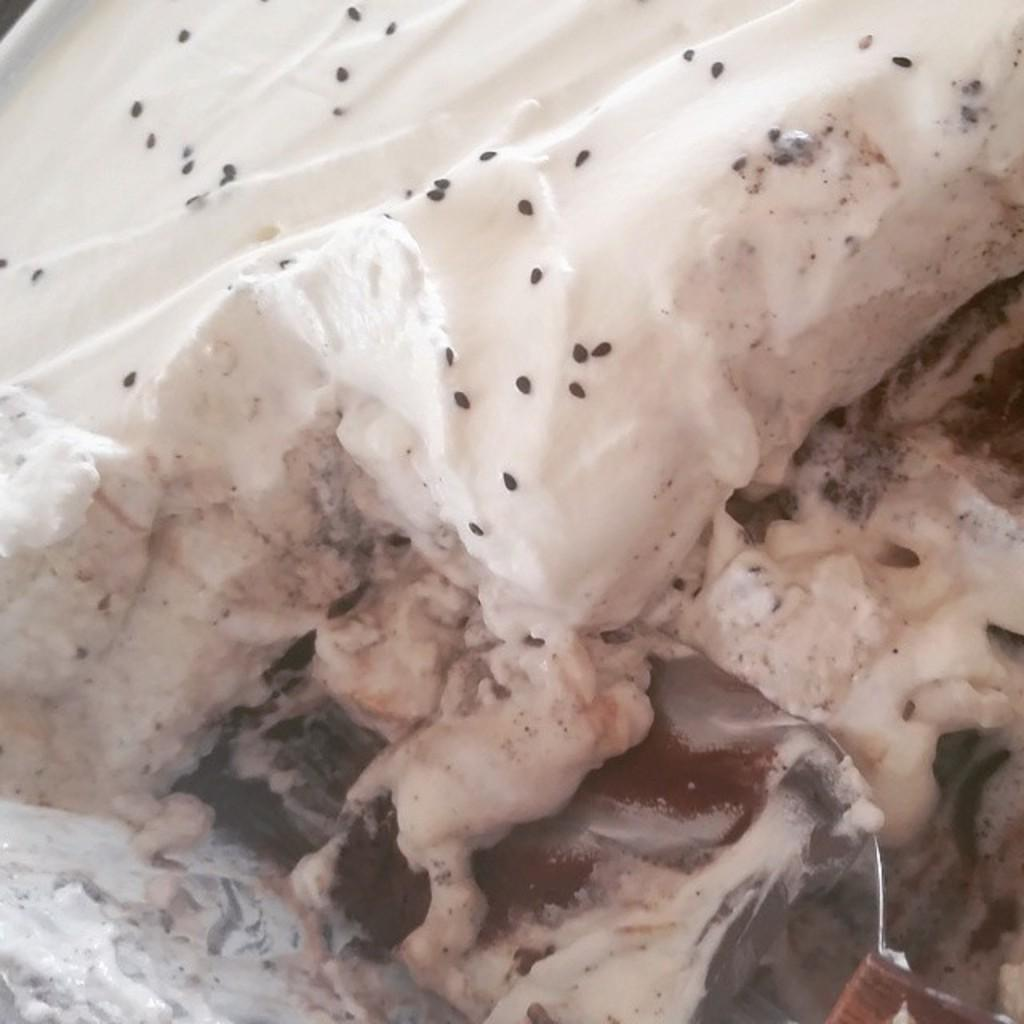What type of food item has white cream in the image? There is a food item with white cream in the image. What other ingredients are present in the food item? The food item has chocolate in it and sesame seeds on it. What utensil is visible in the image? There is a spoon in the image. What is the title of the book that is being read at the party in the image? There is no book or party present in the image; it features a food item with white cream, chocolate, and sesame seeds. 